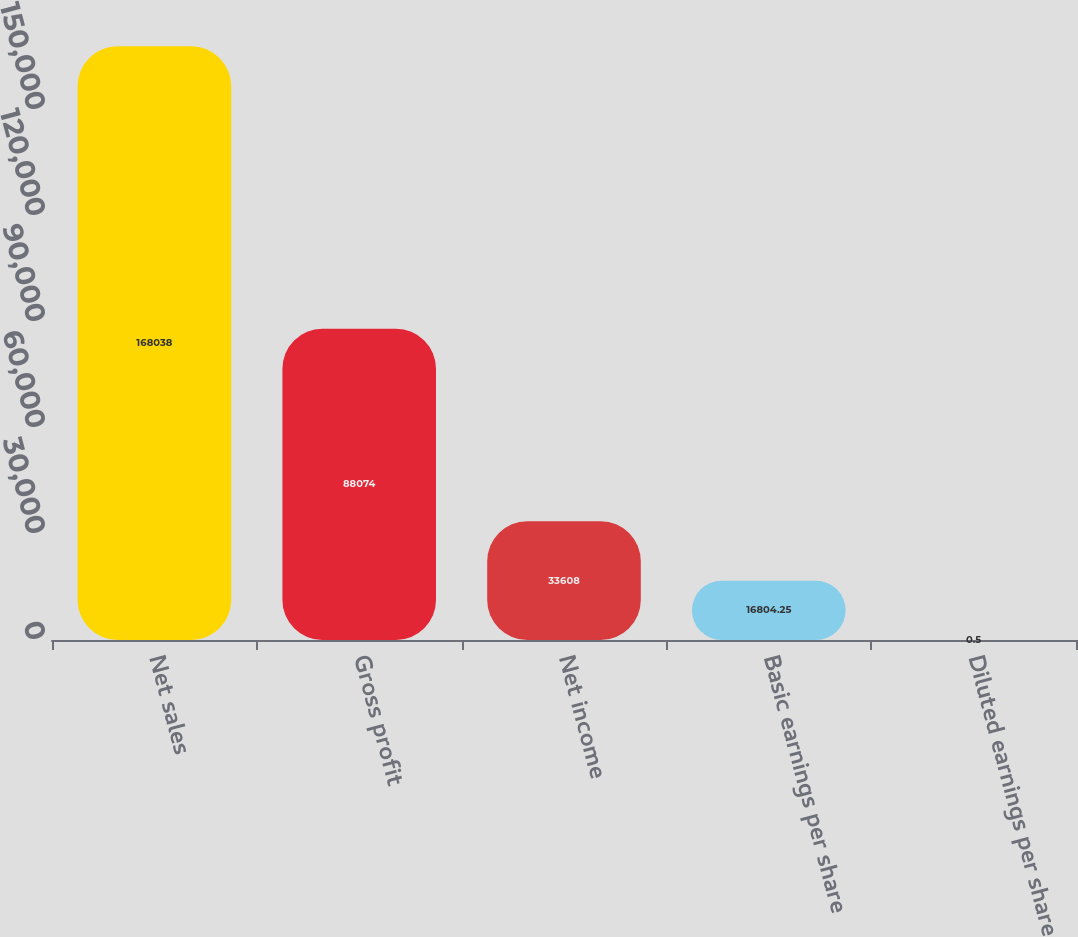<chart> <loc_0><loc_0><loc_500><loc_500><bar_chart><fcel>Net sales<fcel>Gross profit<fcel>Net income<fcel>Basic earnings per share<fcel>Diluted earnings per share<nl><fcel>168038<fcel>88074<fcel>33608<fcel>16804.2<fcel>0.5<nl></chart> 